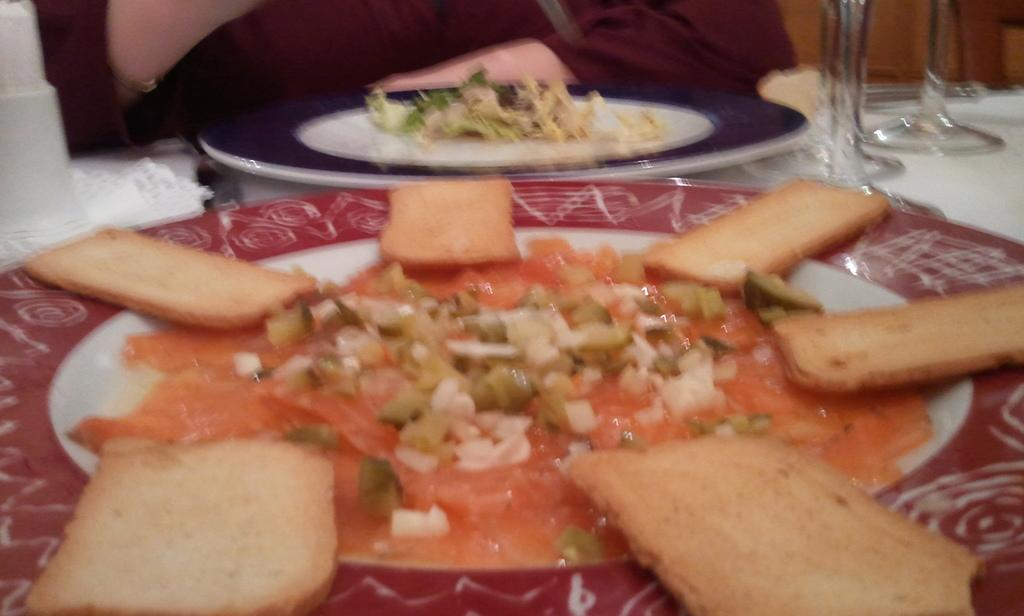What is on the plates that are visible in the image? There are plates with food items in the image. What else can be seen on the table besides the plates? There are glasses visible in the image. Where are the plates and glasses located in the image? The plates and glasses are placed on a table. What flavor of ice cream does the grandfather prefer on vacation? There is no grandfather or ice cream mentioned in the image, so it is not possible to answer that question. 